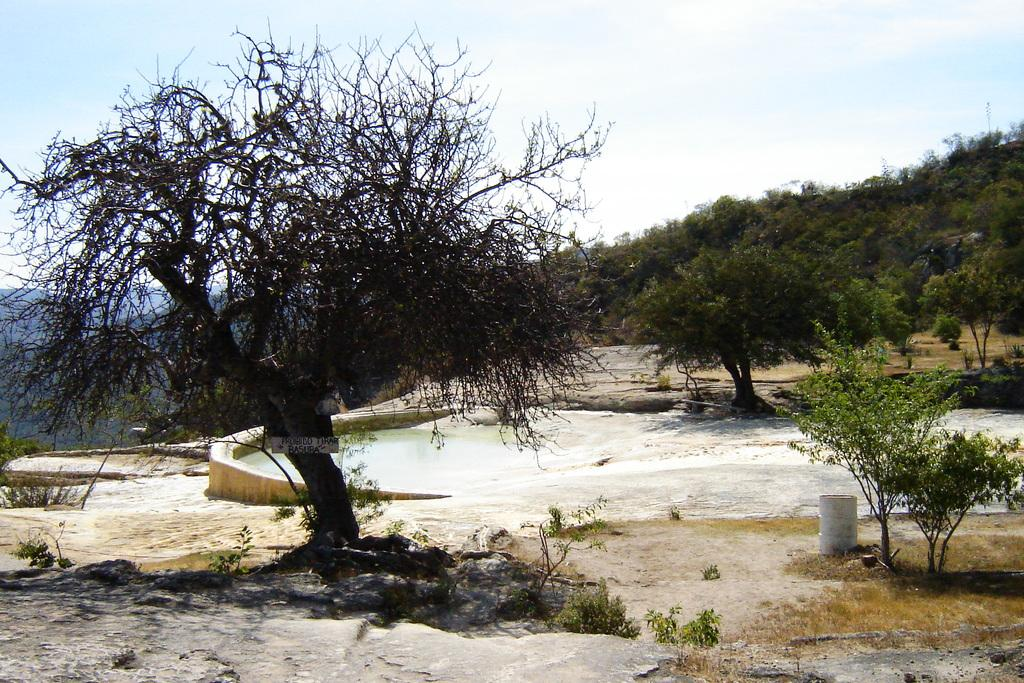What type of geographical feature is present in the image? There are mountains in the image. What is the surface of the mountains like? The mountains have a rocky surface. What type of vegetation can be seen in the image? There are trees in the image. What body of water is present in the image? There is a small water pond in the image. What is visible at the top of the image? The sky is visible at the top of the image. What type of brush is used to clean the teeth of the mountains in the image? There are no brushes or teeth present in the image. 